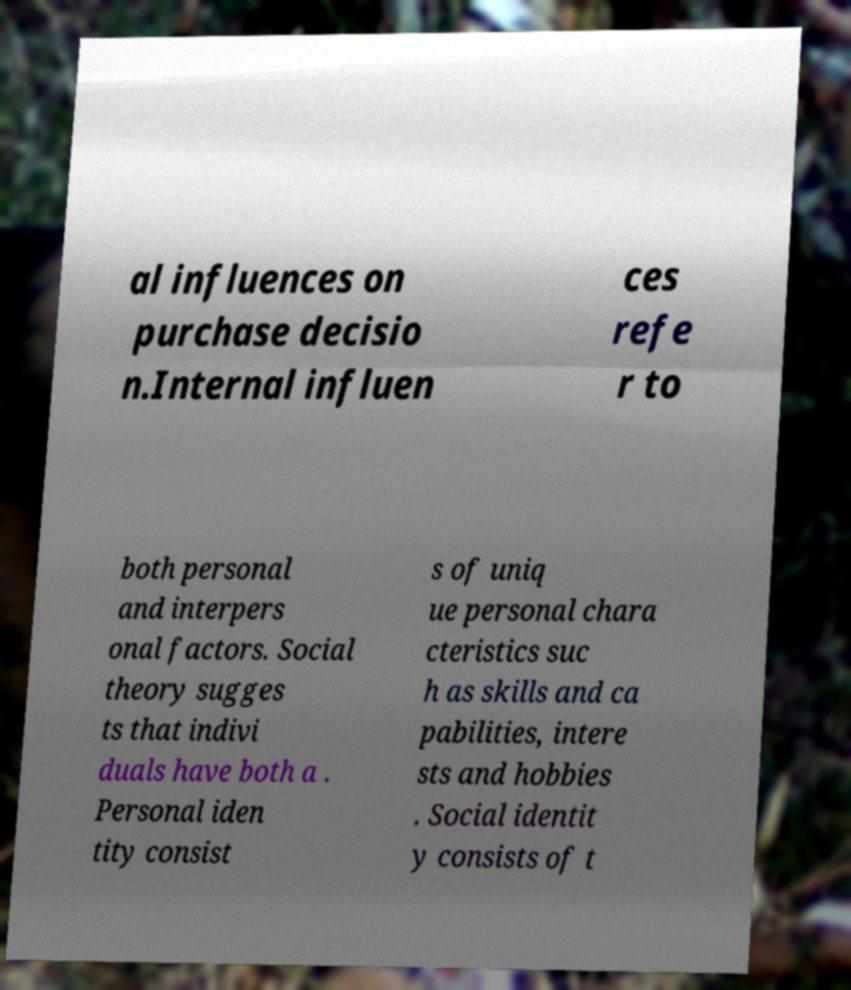For documentation purposes, I need the text within this image transcribed. Could you provide that? al influences on purchase decisio n.Internal influen ces refe r to both personal and interpers onal factors. Social theory sugges ts that indivi duals have both a . Personal iden tity consist s of uniq ue personal chara cteristics suc h as skills and ca pabilities, intere sts and hobbies . Social identit y consists of t 